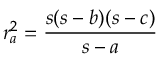Convert formula to latex. <formula><loc_0><loc_0><loc_500><loc_500>r _ { a } ^ { 2 } = { \frac { s ( s - b ) ( s - c ) } { s - a } }</formula> 